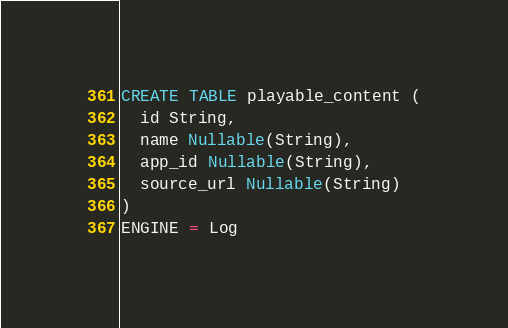Convert code to text. <code><loc_0><loc_0><loc_500><loc_500><_SQL_>CREATE TABLE playable_content (
  id String,
  name Nullable(String),
  app_id Nullable(String),
  source_url Nullable(String)
)
ENGINE = Log
</code> 